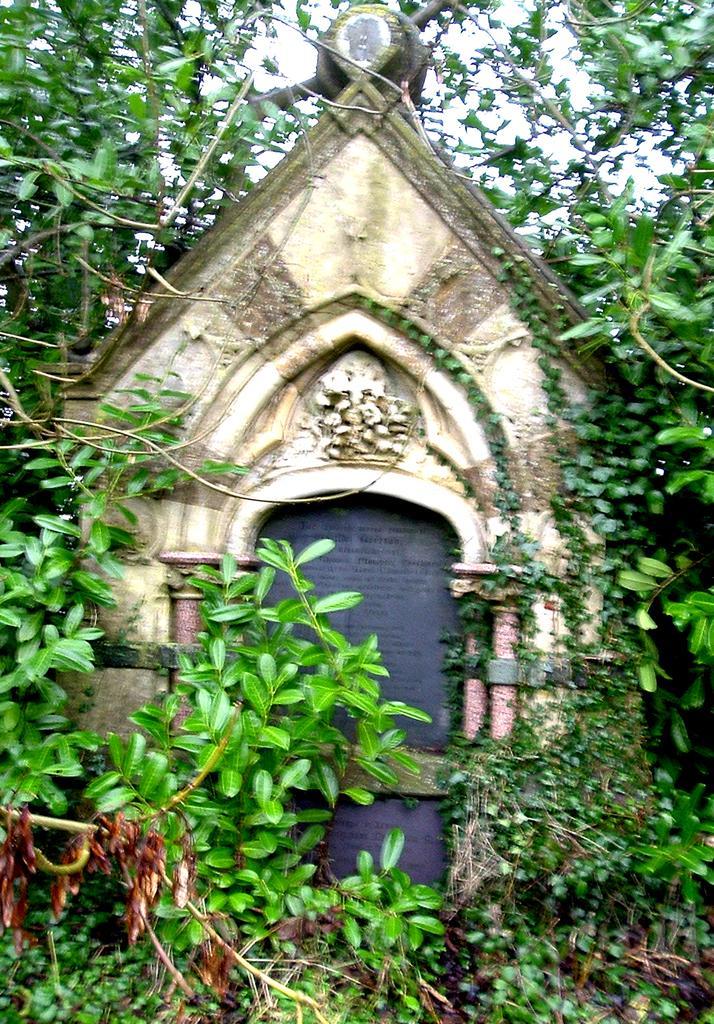Could you give a brief overview of what you see in this image? In this picture I can see there is an arch and there are plants around the arch. In the backdrop, there are trees and the sky is clear. 